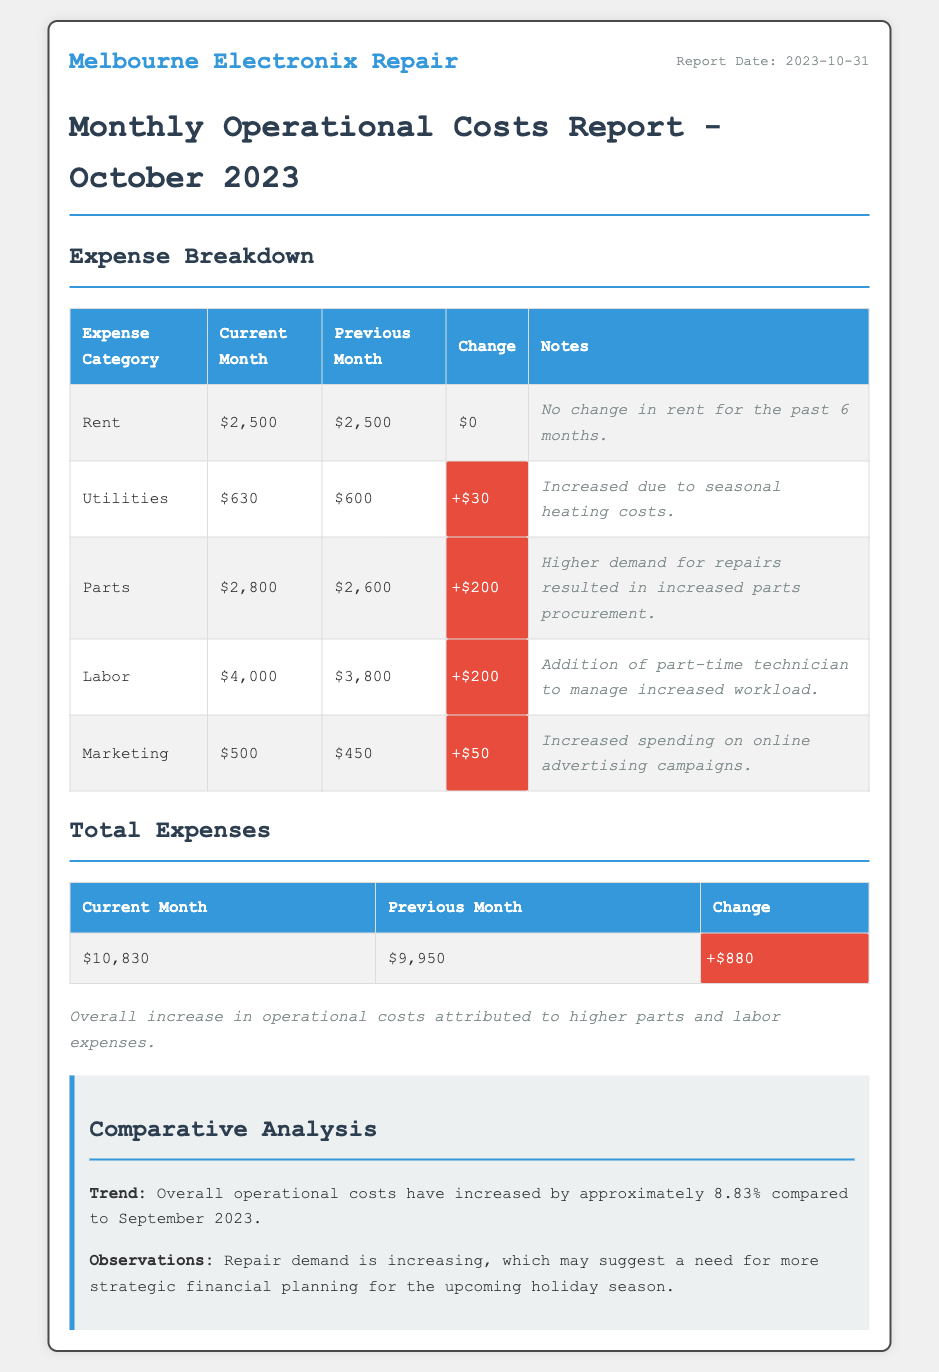What was the total rent expense for October 2023? The total rent expense for October 2023 is listed in the document under the Rent category.
Answer: $2,500 What is the increase in utilities expenses from the previous month? The change in utilities expenses is found in the Utilities row of the Expense Breakdown table.
Answer: $30 What were the total expenses for October 2023? The total expenses are summarized in the Total Expenses table for the current month.
Answer: $10,830 Which expense category had the highest amount in October 2023? The highest expense category can be identified from the Expense Breakdown table based on the Current Month column.
Answer: Labor What is the reason for the increase in parts expenses? The notes in the Parts row explain the reason for the increase.
Answer: Higher demand for repairs What percentage increase do the total expenses show compared to September? The percentage increase is mentioned in the Comparative Analysis section of the document.
Answer: 8.83% What was the amount spent on marketing in October 2023? The amount is listed in the Marketing row of the Expense Breakdown table.
Answer: $500 How long has the rent amount remained unchanged? The notes in the Rent row specify the duration without changes.
Answer: 6 months What was the previous month's total expenses? The previous month's total is noted in the Total Expenses table for reference.
Answer: $9,950 Which expense category reflects spending on advertising? The relevant expense category can be found in the Expense Breakdown table.
Answer: Marketing 